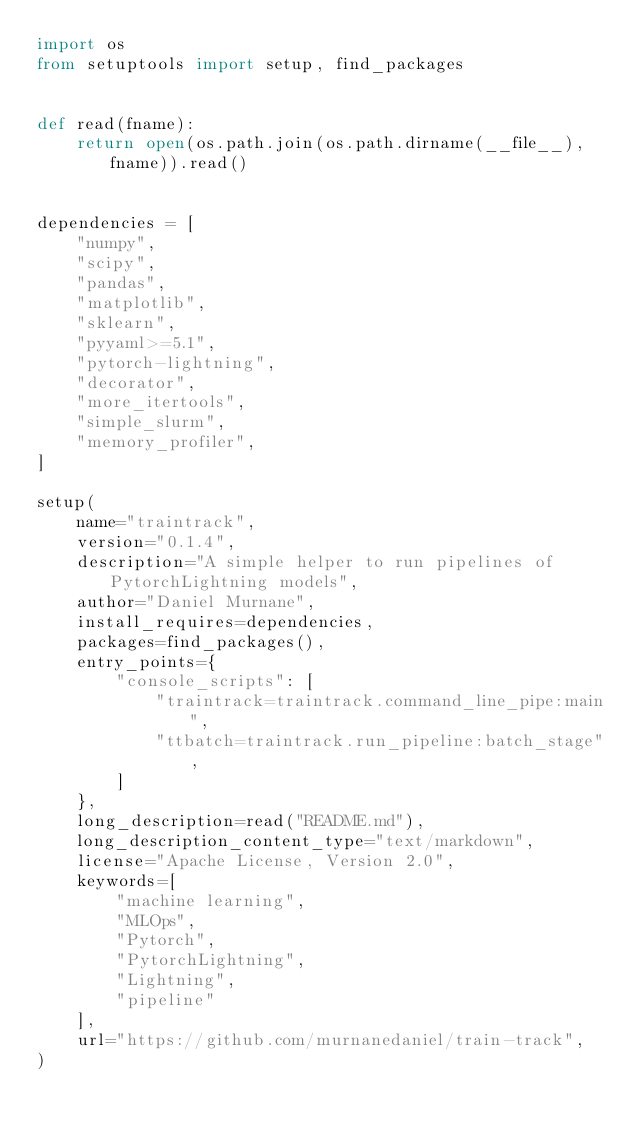Convert code to text. <code><loc_0><loc_0><loc_500><loc_500><_Python_>import os
from setuptools import setup, find_packages


def read(fname):
    return open(os.path.join(os.path.dirname(__file__), fname)).read()


dependencies = [
    "numpy",
    "scipy",
    "pandas",
    "matplotlib",
    "sklearn",
    "pyyaml>=5.1",
    "pytorch-lightning",
    "decorator",
    "more_itertools",
    "simple_slurm",
    "memory_profiler",
]

setup(
    name="traintrack",
    version="0.1.4",
    description="A simple helper to run pipelines of PytorchLightning models",
    author="Daniel Murnane",
    install_requires=dependencies,
    packages=find_packages(),
    entry_points={
        "console_scripts": [
            "traintrack=traintrack.command_line_pipe:main",
            "ttbatch=traintrack.run_pipeline:batch_stage",
        ]
    },
    long_description=read("README.md"),
    long_description_content_type="text/markdown",
    license="Apache License, Version 2.0",
    keywords=[
        "machine learning",
        "MLOps",
        "Pytorch",
        "PytorchLightning",
        "Lightning",
        "pipeline"
    ],
    url="https://github.com/murnanedaniel/train-track",
)
</code> 